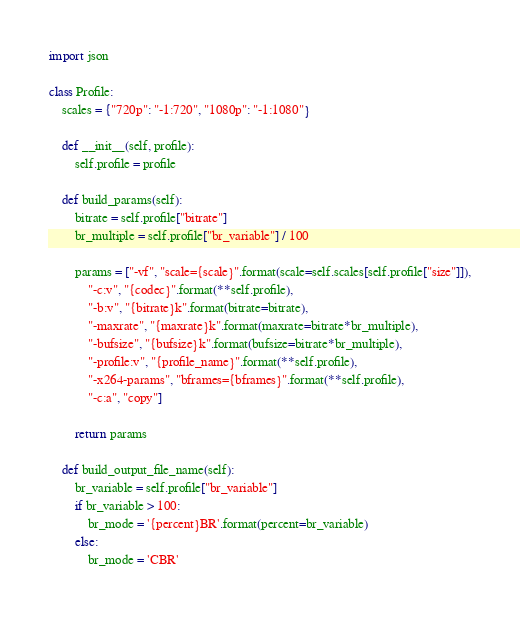Convert code to text. <code><loc_0><loc_0><loc_500><loc_500><_Python_>
import json

class Profile:
    scales = {"720p": "-1:720", "1080p": "-1:1080"}

    def __init__(self, profile):
        self.profile = profile

    def build_params(self):
        bitrate = self.profile["bitrate"]
        br_multiple = self.profile["br_variable"] / 100

        params = ["-vf", "scale={scale}".format(scale=self.scales[self.profile["size"]]),
            "-c:v", "{codec}".format(**self.profile),
            "-b:v", "{bitrate}k".format(bitrate=bitrate),
            "-maxrate", "{maxrate}k".format(maxrate=bitrate*br_multiple),
            "-bufsize", "{bufsize}k".format(bufsize=bitrate*br_multiple),
            "-profile:v", "{profile_name}".format(**self.profile),
            "-x264-params", "bframes={bframes}".format(**self.profile),
            "-c:a", "copy"]

        return params

    def build_output_file_name(self):
        br_variable = self.profile["br_variable"]
        if br_variable > 100:
            br_mode = '{percent}BR'.format(percent=br_variable)
        else:
            br_mode = 'CBR'</code> 